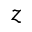Convert formula to latex. <formula><loc_0><loc_0><loc_500><loc_500>z</formula> 